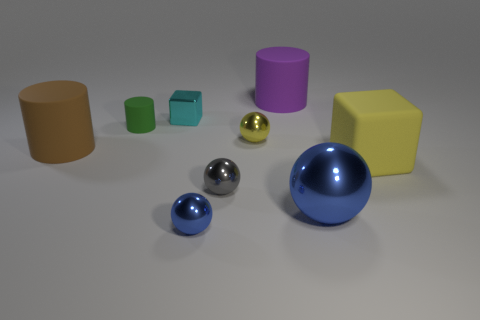What material is the other sphere that is the same color as the large ball?
Your answer should be very brief. Metal. How many things are either tiny metal objects that are in front of the big matte cube or large yellow things?
Your response must be concise. 3. Does the blue metal object left of the purple thing have the same size as the shiny block?
Provide a short and direct response. Yes. Are there fewer green rubber cylinders in front of the tiny yellow object than cyan metal spheres?
Your answer should be compact. No. What material is the ball that is the same size as the purple cylinder?
Ensure brevity in your answer.  Metal. What number of large objects are metal balls or purple objects?
Offer a terse response. 2. How many things are matte objects that are to the left of the big block or small spheres that are behind the large blue ball?
Keep it short and to the point. 5. Are there fewer big yellow blocks than tiny blue metal cubes?
Keep it short and to the point. No. There is a brown matte object that is the same size as the purple rubber cylinder; what shape is it?
Offer a terse response. Cylinder. How many other objects are there of the same color as the tiny rubber cylinder?
Give a very brief answer. 0. 